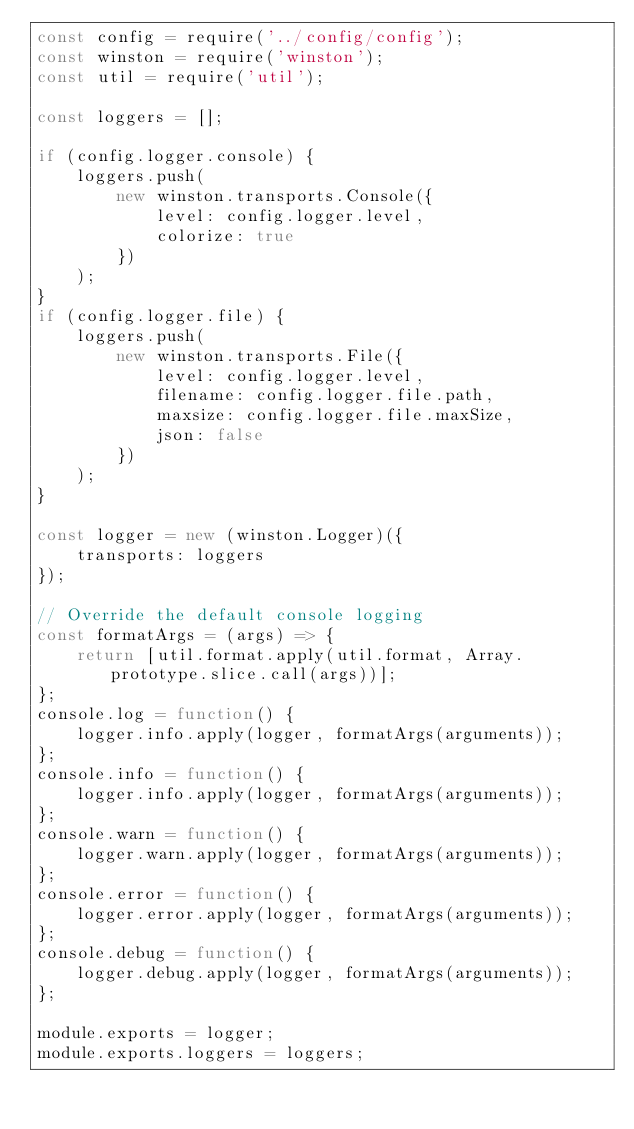Convert code to text. <code><loc_0><loc_0><loc_500><loc_500><_JavaScript_>const config = require('../config/config');
const winston = require('winston');
const util = require('util');

const loggers = [];

if (config.logger.console) {
    loggers.push(
        new winston.transports.Console({
            level: config.logger.level,
            colorize: true
        })
    );
}
if (config.logger.file) {
    loggers.push(
        new winston.transports.File({
            level: config.logger.level,
            filename: config.logger.file.path,
            maxsize: config.logger.file.maxSize,
            json: false
        })
    );
}

const logger = new (winston.Logger)({
    transports: loggers
});

// Override the default console logging
const formatArgs = (args) => {
    return [util.format.apply(util.format, Array.prototype.slice.call(args))];
};
console.log = function() {
    logger.info.apply(logger, formatArgs(arguments));
};
console.info = function() {
    logger.info.apply(logger, formatArgs(arguments));
};
console.warn = function() {
    logger.warn.apply(logger, formatArgs(arguments));
};
console.error = function() {
    logger.error.apply(logger, formatArgs(arguments));
};
console.debug = function() {
    logger.debug.apply(logger, formatArgs(arguments));
};

module.exports = logger;
module.exports.loggers = loggers;
</code> 